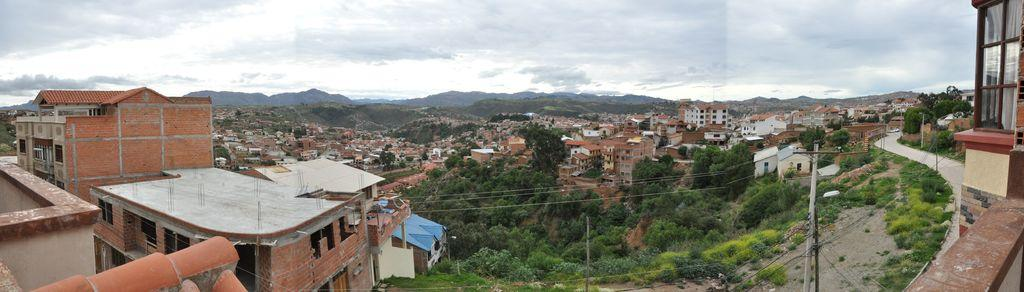What type of structure is visible in the image? There is a building with windows in the image. What natural elements can be seen in the image? There are trees and mountains in the image. What man-made objects are present in the image? There are poles in the image. What is visible in the background of the image? The sky is visible in the background of the image. What atmospheric conditions can be observed in the sky? Clouds are present in the sky. How many gates are present in the image? There are no gates visible in the image. What type of zipper can be seen on the trees in the image? There are no zippers present on the trees in the image. 